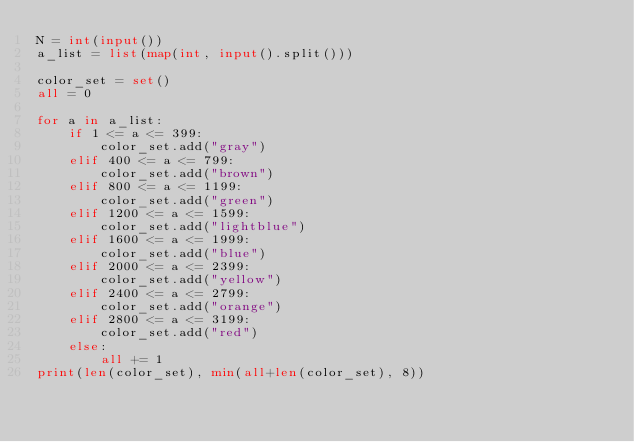<code> <loc_0><loc_0><loc_500><loc_500><_Python_>N = int(input())
a_list = list(map(int, input().split()))

color_set = set()
all = 0

for a in a_list:
    if 1 <= a <= 399:
        color_set.add("gray")
    elif 400 <= a <= 799:
        color_set.add("brown")
    elif 800 <= a <= 1199:
        color_set.add("green")
    elif 1200 <= a <= 1599:
        color_set.add("lightblue")
    elif 1600 <= a <= 1999:
        color_set.add("blue")
    elif 2000 <= a <= 2399:
        color_set.add("yellow")
    elif 2400 <= a <= 2799:
        color_set.add("orange")
    elif 2800 <= a <= 3199:
        color_set.add("red")
    else:
        all += 1
print(len(color_set), min(all+len(color_set), 8))</code> 